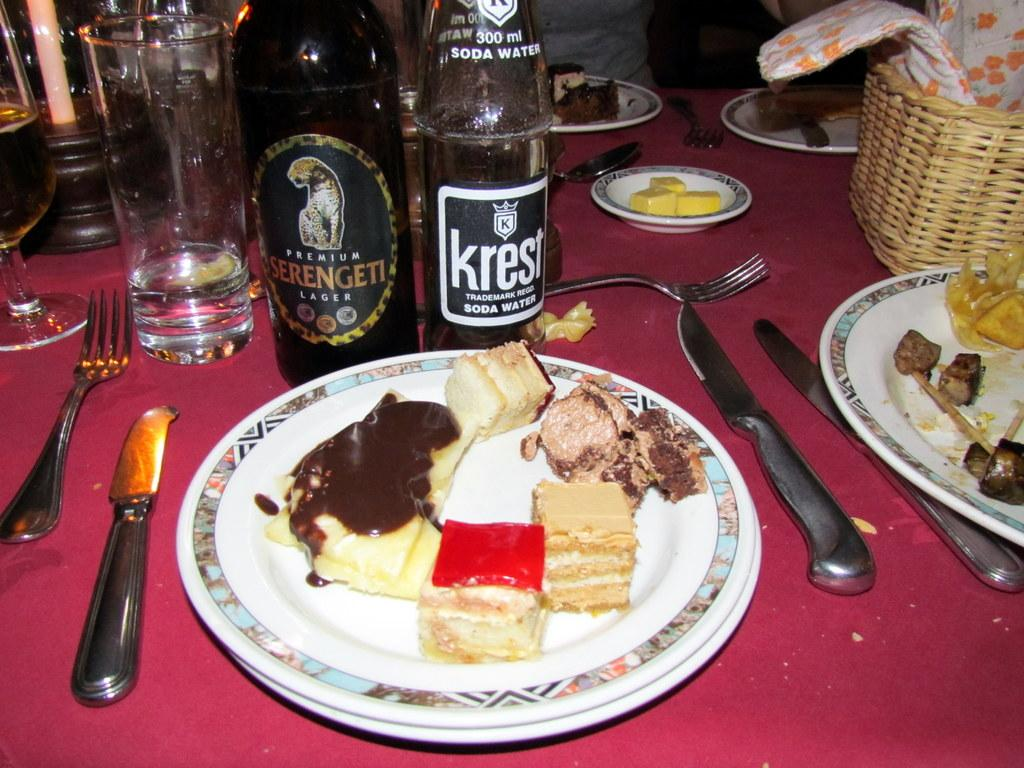<image>
Create a compact narrative representing the image presented. Plates of food, a bottle of Premium Serengeti Lager and a bottle of Krest Soda Water 